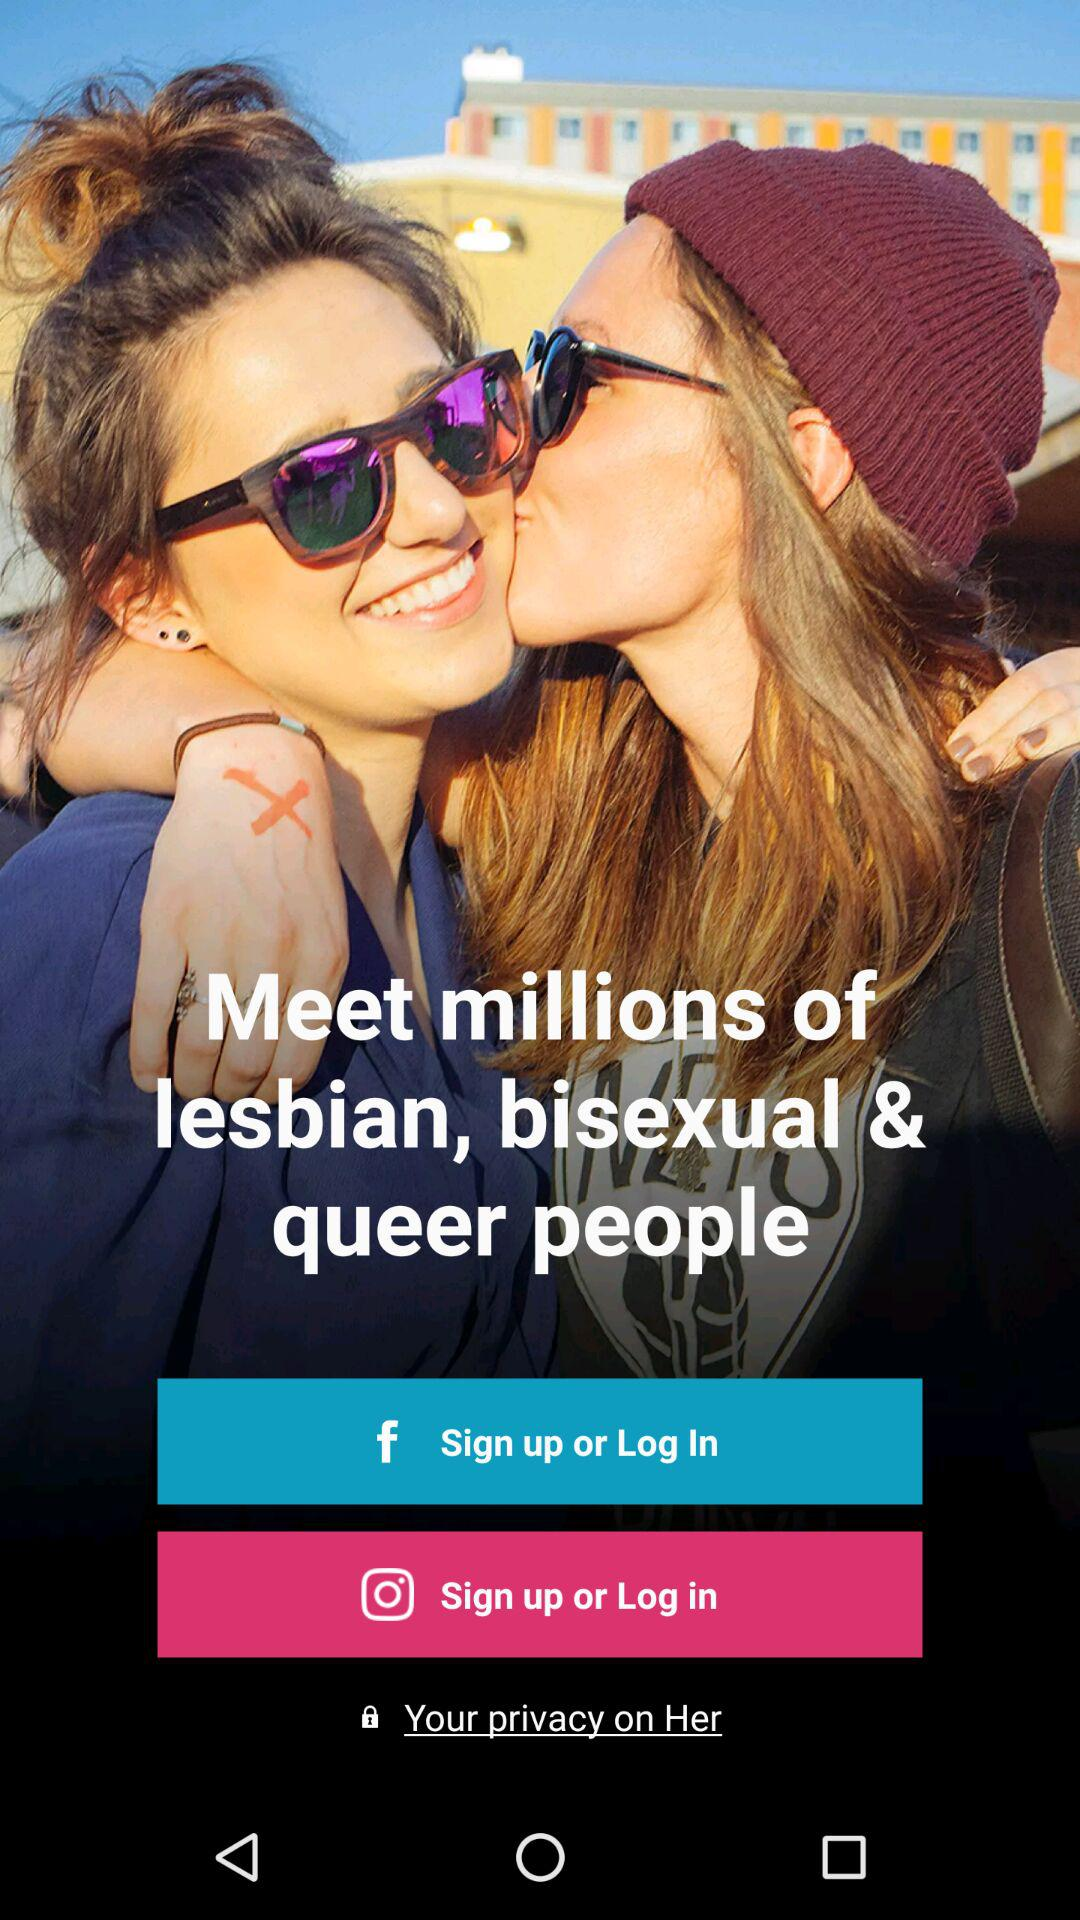What applications can be used to log in or sign up? The applications that can be used to log in or sign up are "Facebook" and "Instagram". 